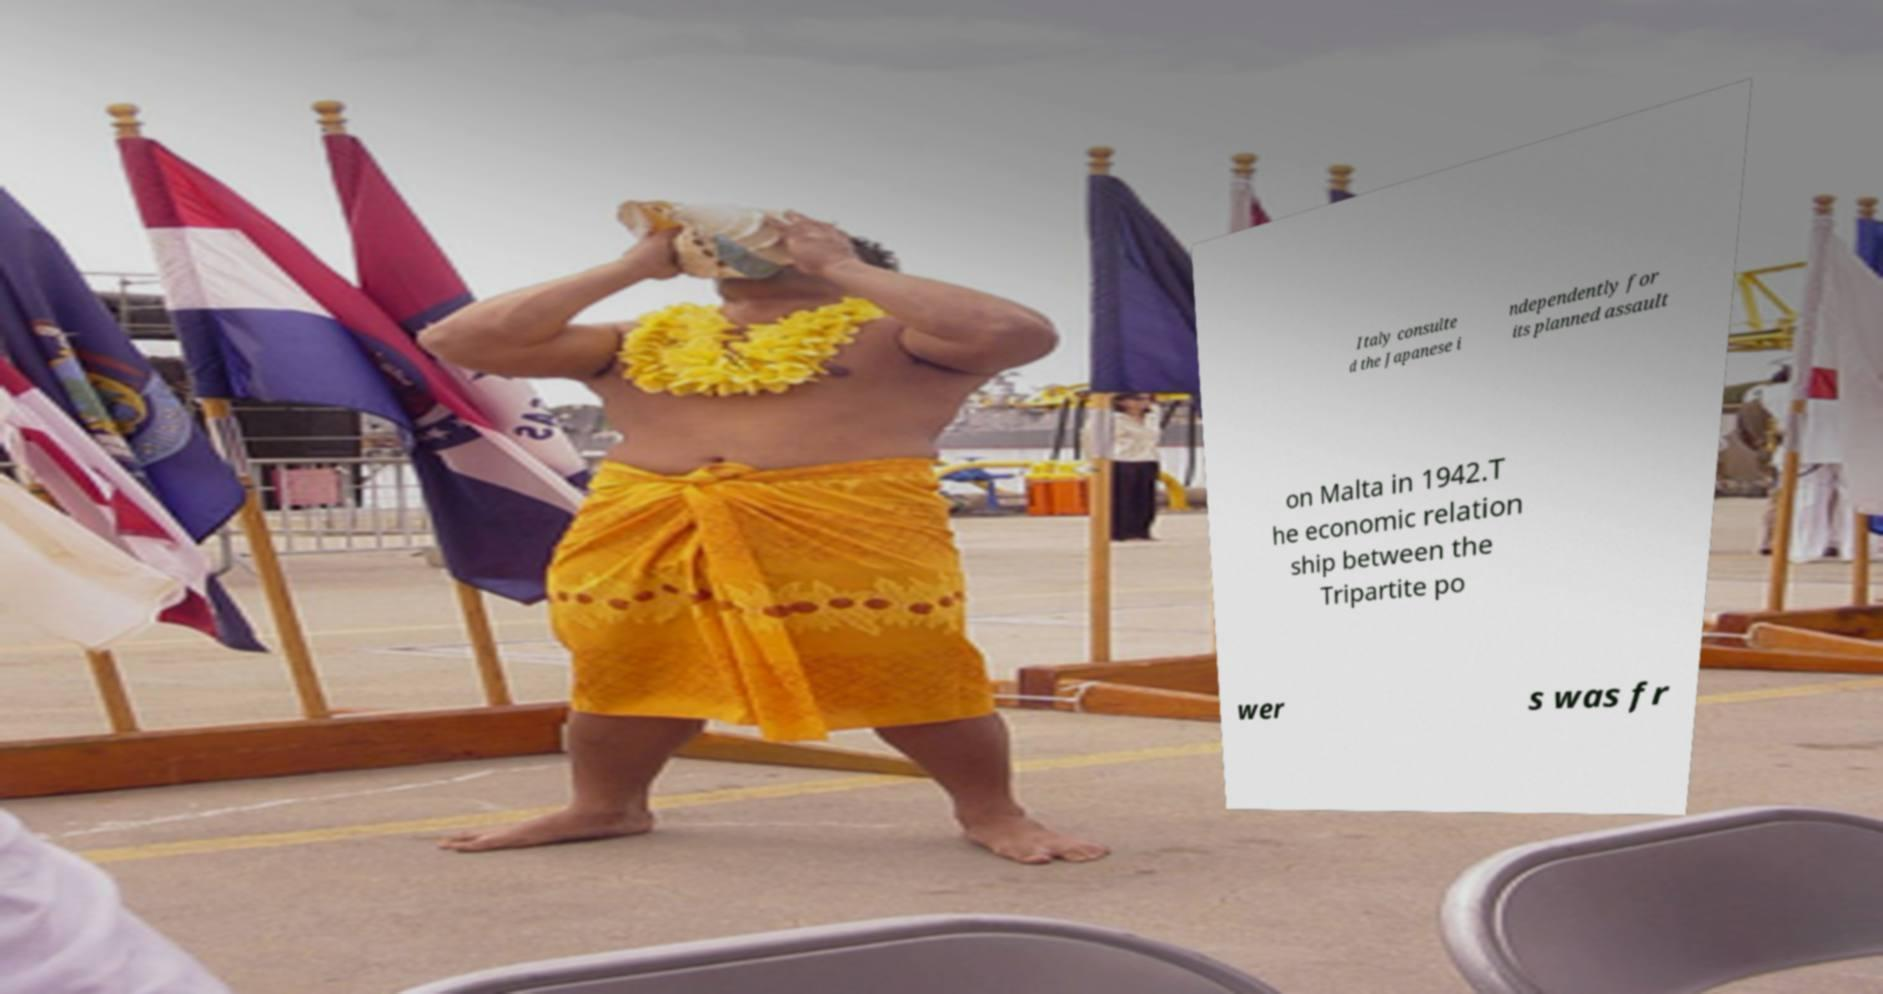Please identify and transcribe the text found in this image. Italy consulte d the Japanese i ndependently for its planned assault on Malta in 1942.T he economic relation ship between the Tripartite po wer s was fr 